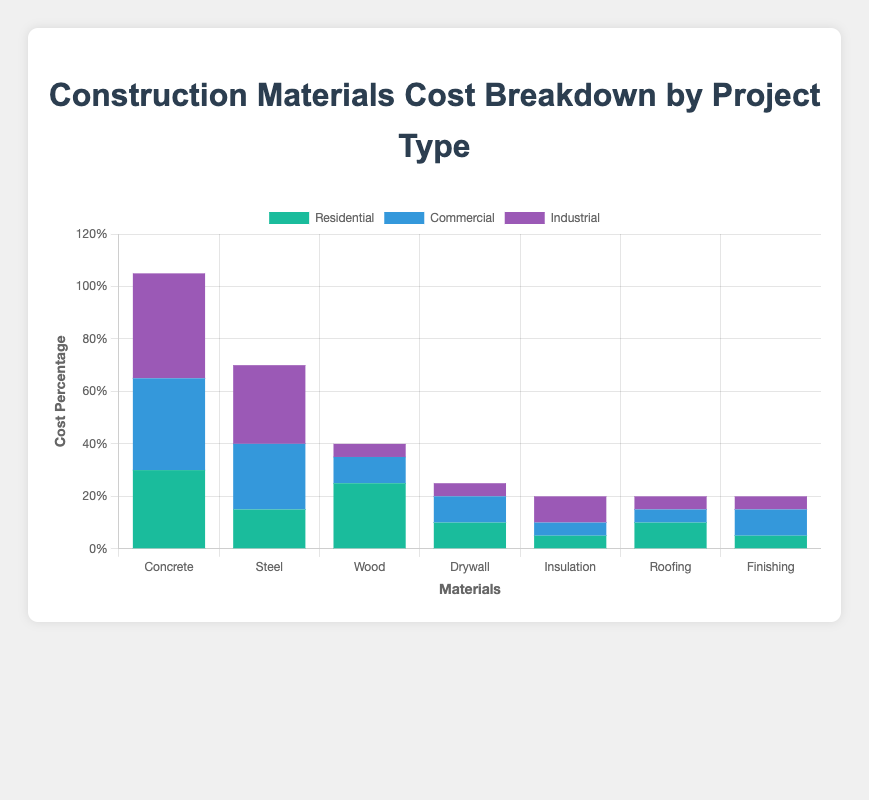Which material has the highest cost percentage for Residential projects? The material with the highest cost percentage for Residential projects can be found by looking at the heights of the bars in the Residential section. The tallest bar corresponds to Concrete with 30%.
Answer: Concrete Which project type has the highest percentage of Steel usage? By comparing the heights of the Steel bars across all project types, we see that Industrial projects have the highest Steel usage at 30%.
Answer: Industrial What is the total cost percentage of Roofing and Finishing for Commercial projects? For Commercial projects, Roofing is 5% and Finishing is 10%. Summing these percentages: 5 + 10 = 15%.
Answer: 15% Which material has the smallest cost percentage in Industrial projects? Looking at the Industrial project type, the material with the smallest percentage is Wood and Roof, which both have 5%.
Answer: Wood, Roof How does the cost percentage of Drywall in Residential projects compare to that in Industrial projects? In Residential projects, Drywall is 10%. In Industrial projects, Drywall is 5%. Therefore, the Drywall cost percentage is higher in Residential projects.
Answer: Higher in Residential What is the combined cost percentage of Glass and Insulation in Commercial projects? Adding the percentages for Glass (10%) and Insulation (5%) in Commercial projects gives 10 + 5 = 15%.
Answer: 15% What material contributes the least to the cost in Residential projects and what is its percentage? Looking at the Residential section, Insulation and Finishing each have the lowest percentage at 5%.
Answer: Insulation, Finishing, 5% Which project type uses Concrete the most extensively? Examining the bars for Concrete across all project types, Industrial projects have the highest use of Concrete at 40%.
Answer: Industrial 